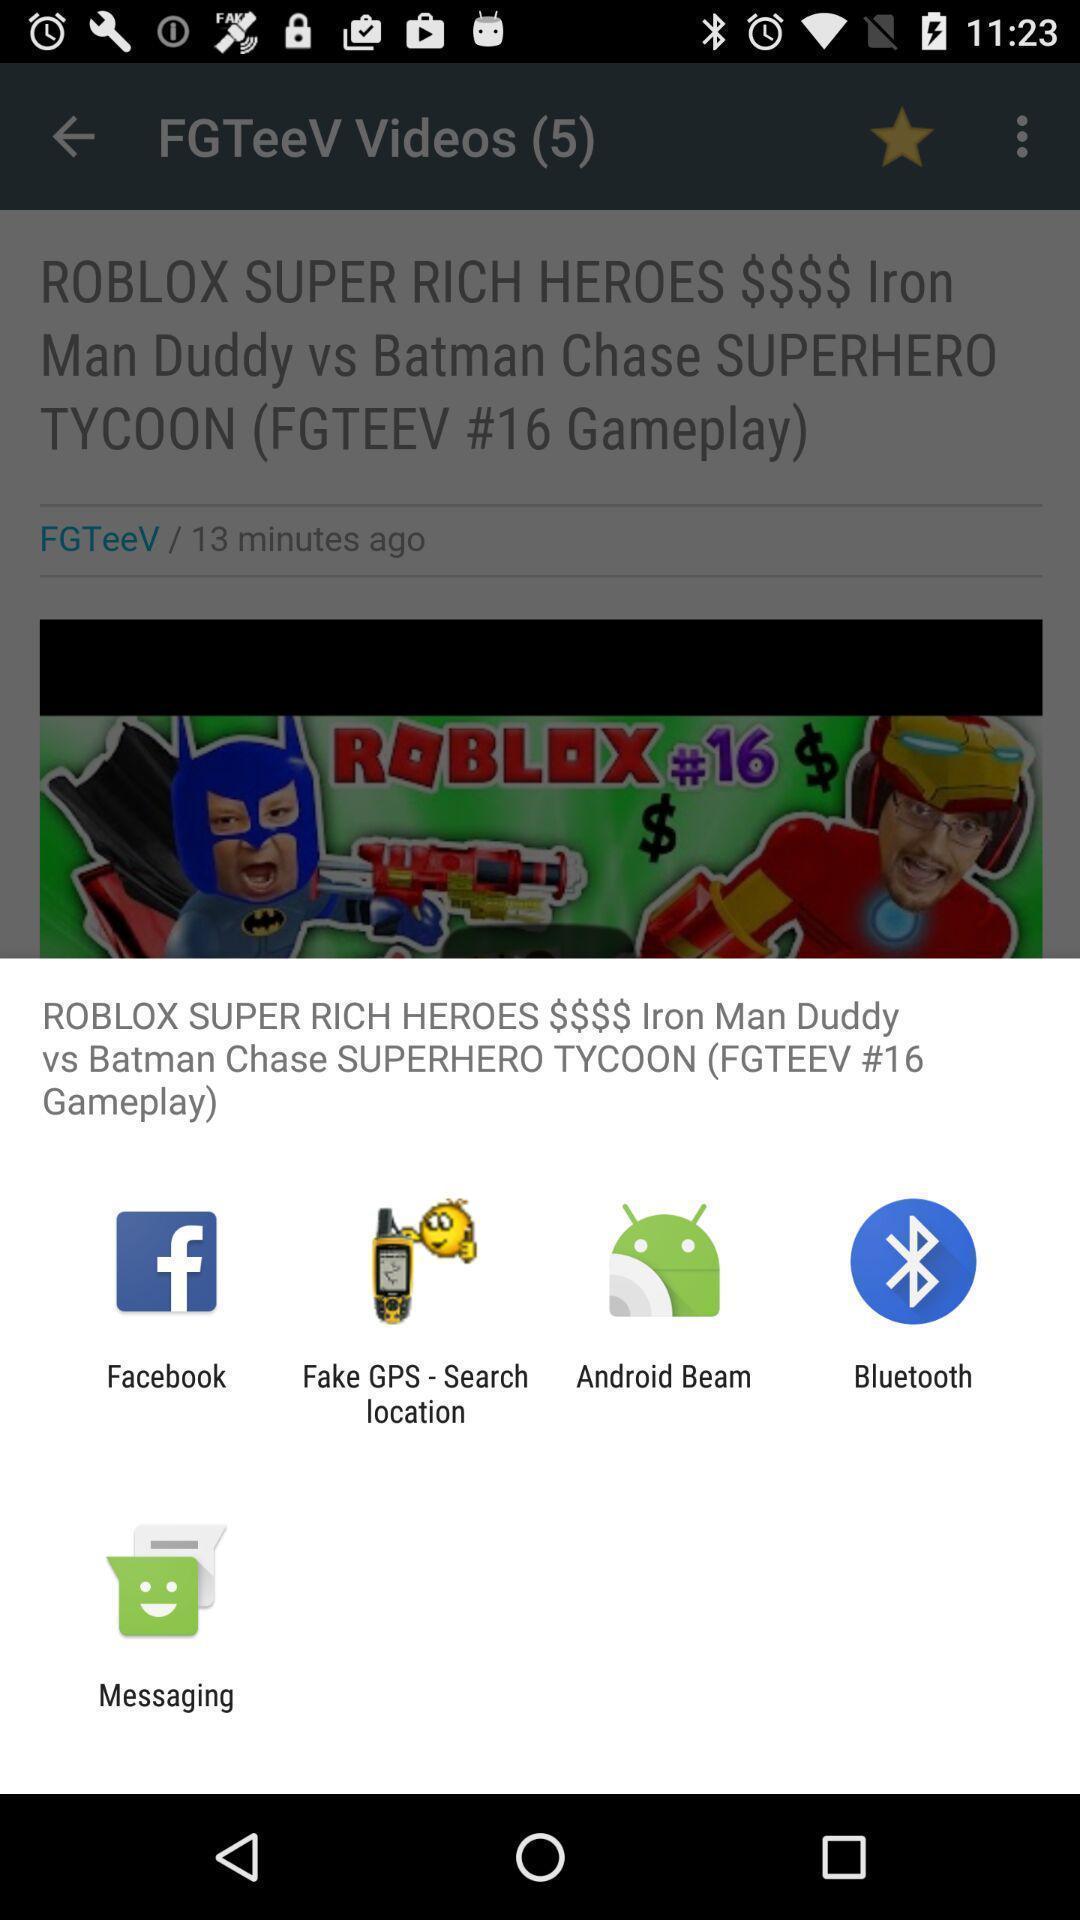What is the overall content of this screenshot? Pop up showing various apps. 